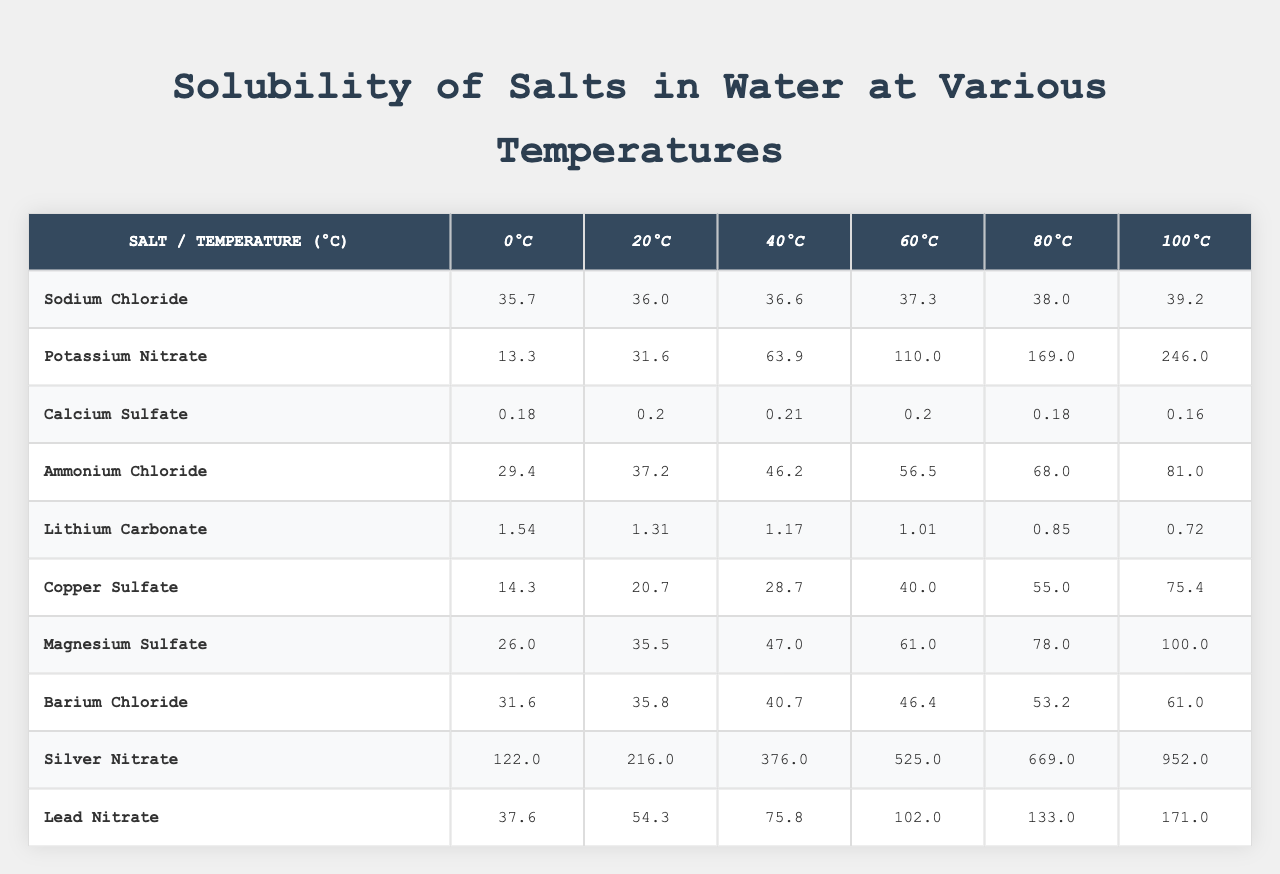What is the solubility of potassium nitrate at 100°C? From the table, under the column for potassium nitrate at 100°C, the value is 246.0 grams per 100 ml of water.
Answer: 246.0 grams Which salt has the highest solubility at 60°C? Looking at the 60°C row, the highest value among all salts is for silver nitrate, which has a solubility of 525.0 grams.
Answer: Silver nitrate What is the difference in solubility of sodium chloride between 0°C and 80°C? At 0°C, sodium chloride has a solubility of 35.7 grams, and at 80°C, it is 38.0 grams. The difference is 38.0 - 35.7 = 2.3 grams.
Answer: 2.3 grams What is the average solubility of ammonium chloride across all temperatures? To find the average, we sum the solubility values of ammonium chloride (29.4 + 37.2 + 46.2 + 56.5 + 68.0 + 81.0 = 318.3) and divide by the number of measurements (6), yielding 318.3 / 6 = 53.05.
Answer: 53.05 grams Is calcium sulfate more soluble at 20°C or at 40°C? At 20°C, the solubility of calcium sulfate is 0.20 grams, and at 40°C, it is 0.21 grams. So, it is more soluble at 40°C.
Answer: Yes Which salt shows a decrease in solubility as temperature increases? Checking the table, lithium carbonate consistently shows decreasing solubility from 1.54 grams at 0°C to 0.72 grams at 100°C.
Answer: Lithium carbonate What is the solubility range of magnesium sulfate from 0°C to 100°C? The solubility at 0°C is 26.0 grams and at 100°C is 100.0 grams. The range is from 26.0 to 100.0 grams.
Answer: 26.0 to 100.0 grams What is the total solubility of barium chloride and copper sulfate at 40°C? At 40°C, barium chloride has a solubility of 40.7 grams, and copper sulfate has 28.7 grams. The total is 40.7 + 28.7 = 69.4 grams.
Answer: 69.4 grams How does the solubility of silver nitrate change from 20°C to 100°C? At 20°C, silver nitrate has a solubility of 216.0 grams, and at 100°C, it increases to 952.0 grams. This change shows a significant increase of 952.0 - 216.0 = 736.0 grams.
Answer: Increased by 736.0 grams Which salt has a solubility of less than 1 gram at 0°C? Referring to the table, lithium carbonate has a solubility of 1.54 grams, which is more than 1 gram, thus no salts fall below that threshold at 0°C.
Answer: No salts 